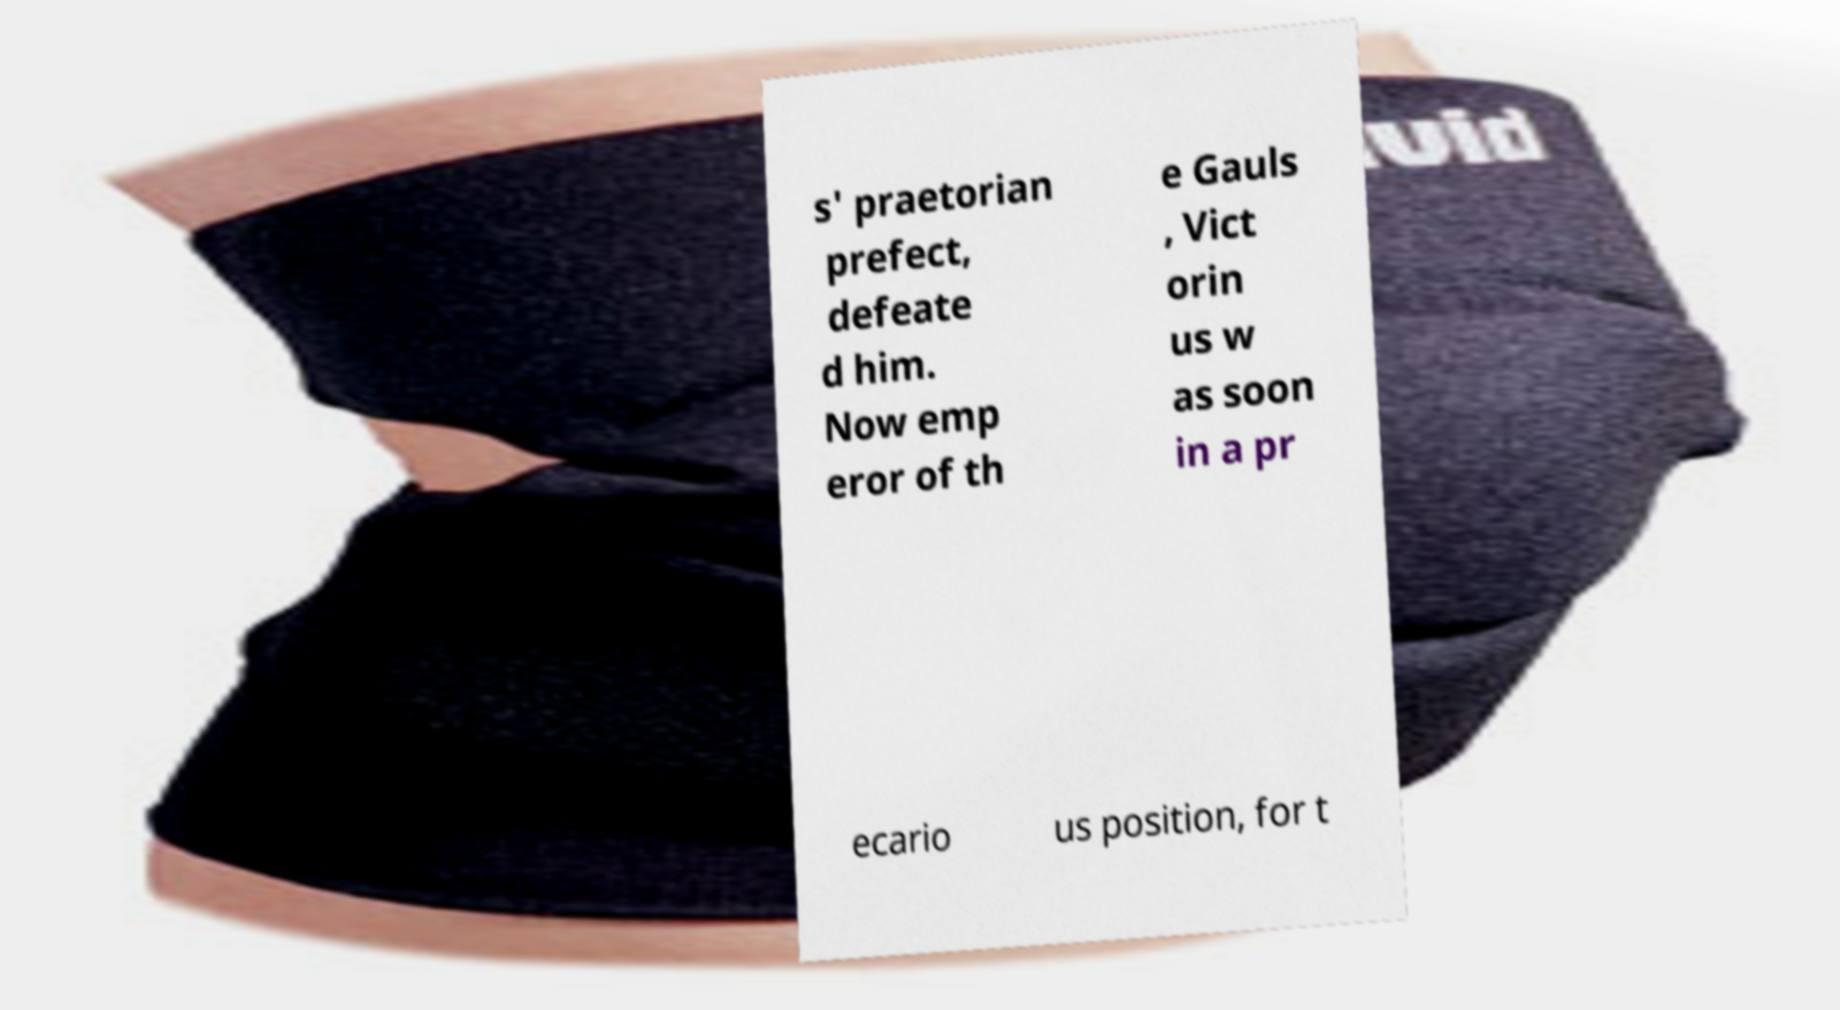For documentation purposes, I need the text within this image transcribed. Could you provide that? s' praetorian prefect, defeate d him. Now emp eror of th e Gauls , Vict orin us w as soon in a pr ecario us position, for t 